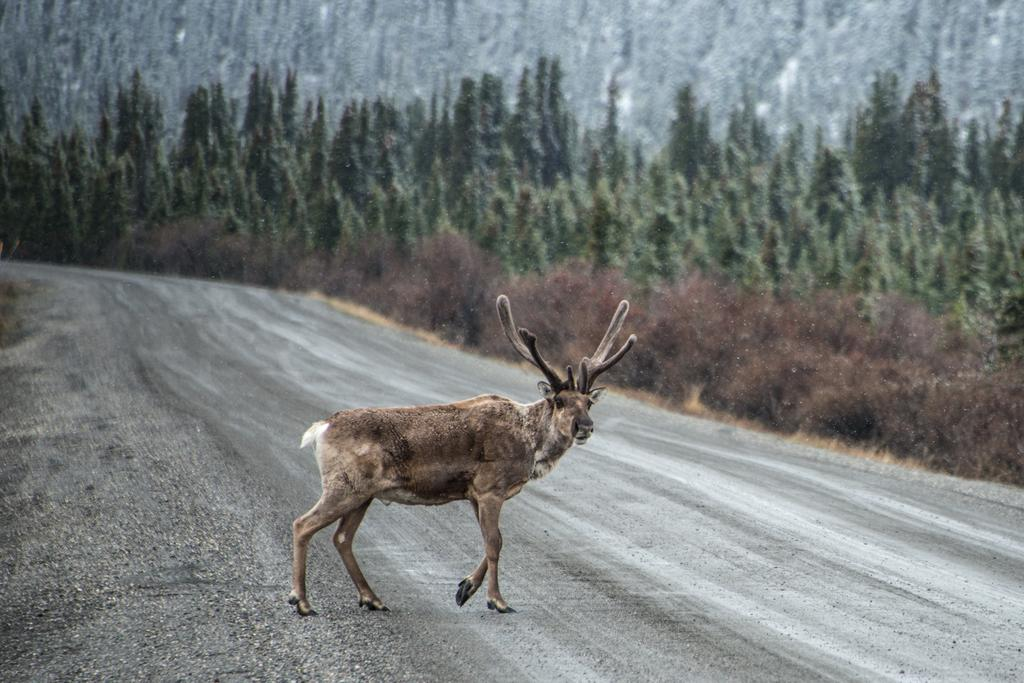What animal is in the center of the image? There is a deer in the center of the image. What can be seen in the background of the image? There are trees in the background of the image. How many planes are visible on the page in the image? There are no planes visible on any page in the image, as it features a deer and trees. 